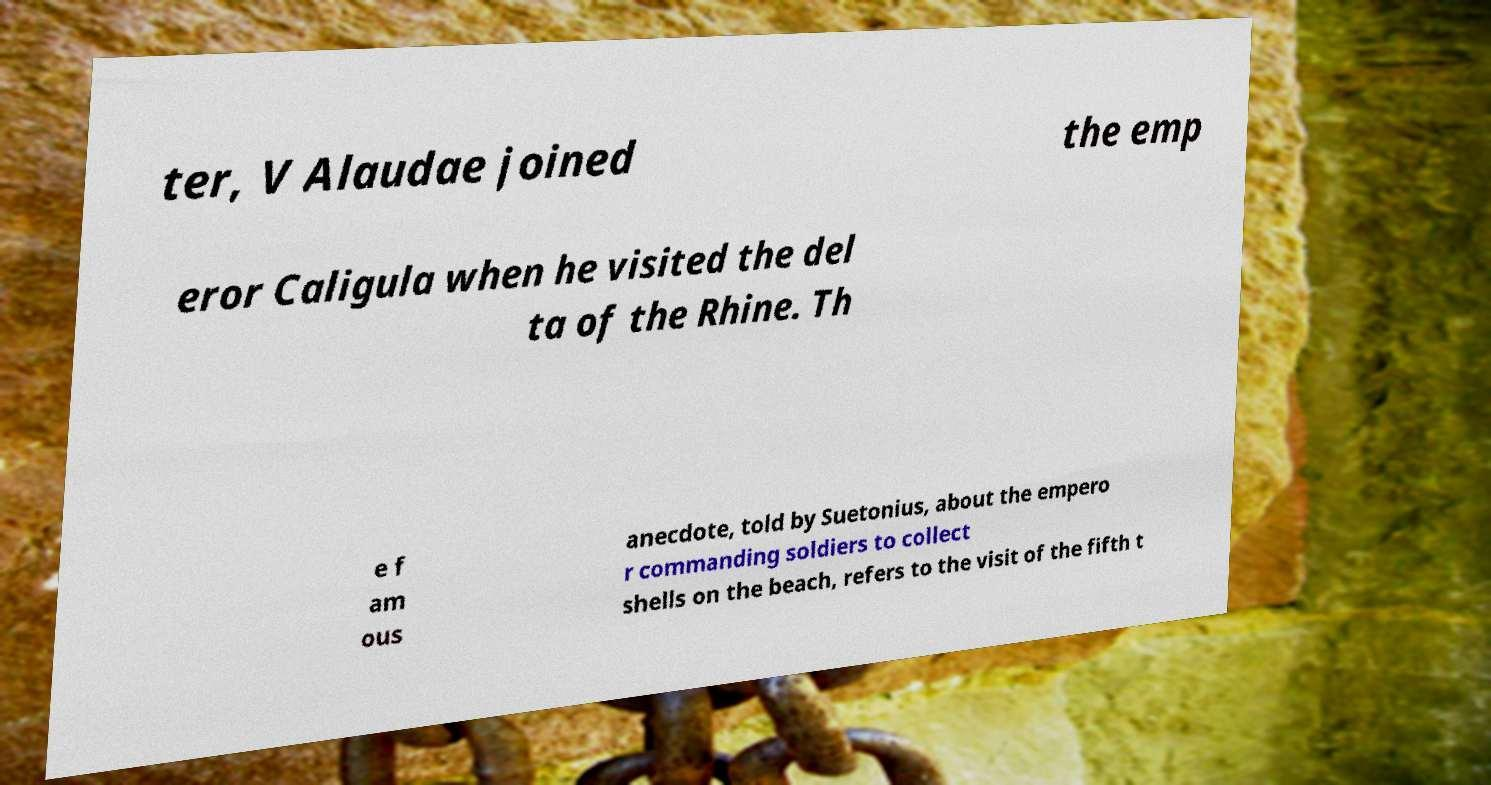For documentation purposes, I need the text within this image transcribed. Could you provide that? ter, V Alaudae joined the emp eror Caligula when he visited the del ta of the Rhine. Th e f am ous anecdote, told by Suetonius, about the empero r commanding soldiers to collect shells on the beach, refers to the visit of the fifth t 